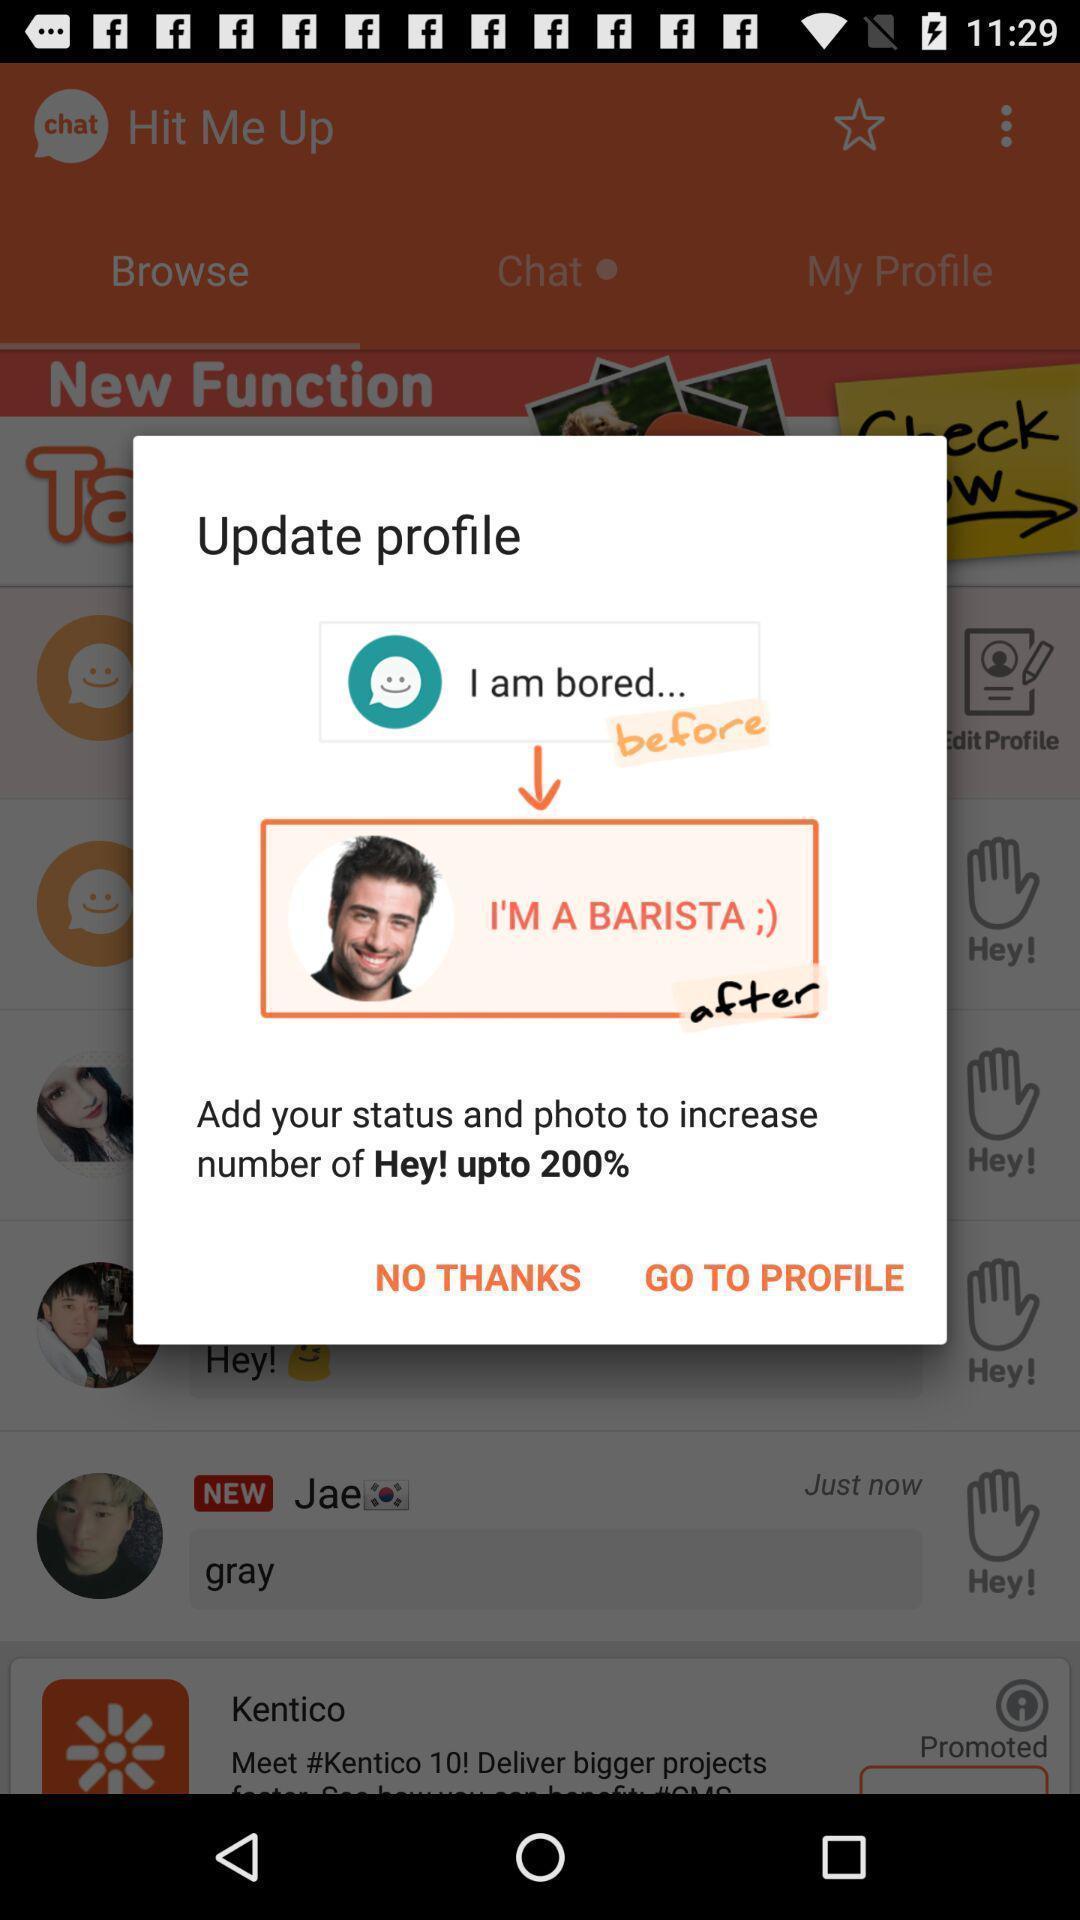Provide a detailed account of this screenshot. Pop up showing update profile. 